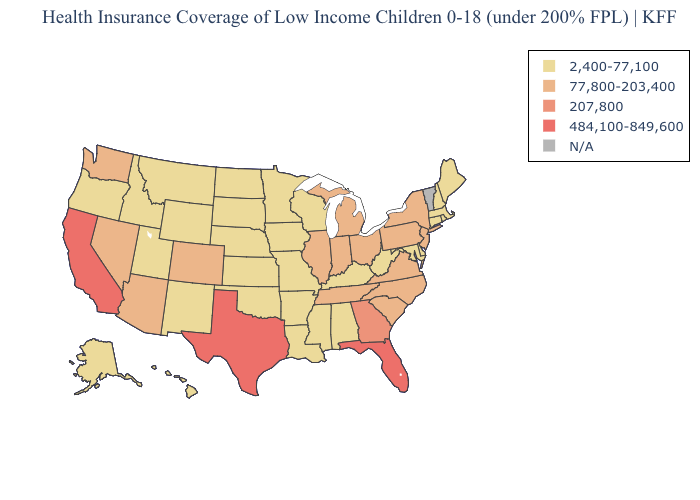What is the lowest value in states that border New Mexico?
Short answer required. 2,400-77,100. Which states have the highest value in the USA?
Keep it brief. California, Florida, Texas. What is the lowest value in states that border New Hampshire?
Concise answer only. 2,400-77,100. What is the highest value in the USA?
Write a very short answer. 484,100-849,600. Does Oregon have the highest value in the USA?
Be succinct. No. What is the value of Indiana?
Concise answer only. 77,800-203,400. Name the states that have a value in the range N/A?
Quick response, please. Vermont. What is the lowest value in the South?
Short answer required. 2,400-77,100. What is the value of Alabama?
Be succinct. 2,400-77,100. What is the value of Utah?
Answer briefly. 2,400-77,100. Does Indiana have the lowest value in the USA?
Answer briefly. No. Among the states that border California , does Oregon have the lowest value?
Concise answer only. Yes. What is the lowest value in the South?
Concise answer only. 2,400-77,100. Which states have the highest value in the USA?
Answer briefly. California, Florida, Texas. 